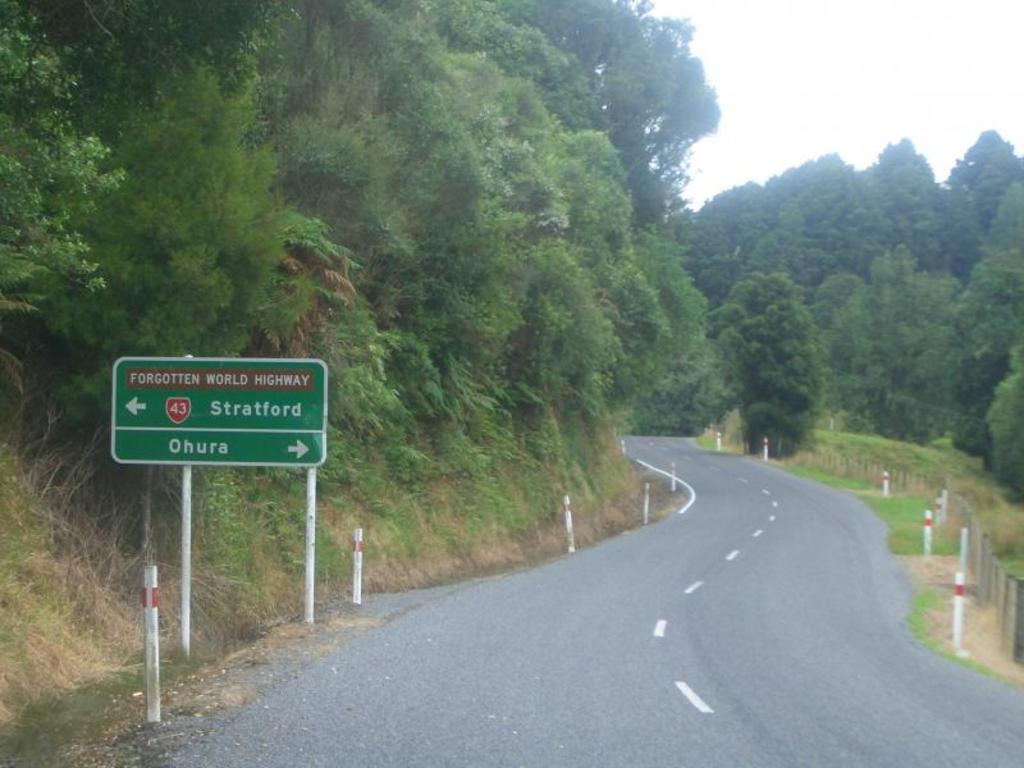<image>
Relay a brief, clear account of the picture shown. A road sign on the Forgotten World Highway shows the directions to Stratford and Ohura. 